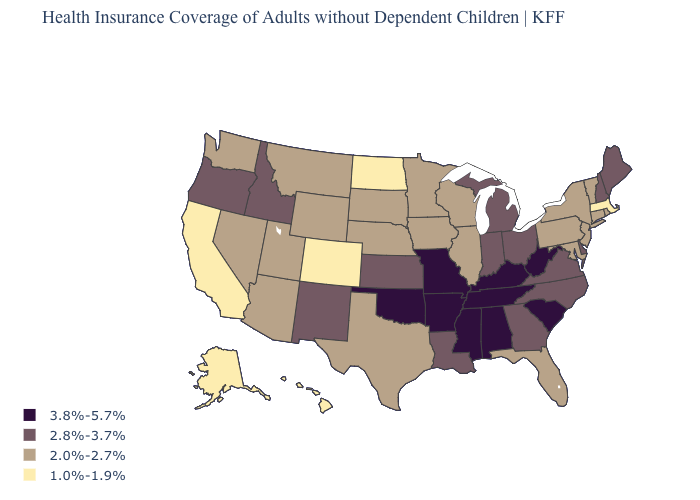What is the highest value in the USA?
Be succinct. 3.8%-5.7%. Among the states that border Kentucky , which have the lowest value?
Quick response, please. Illinois. Name the states that have a value in the range 1.0%-1.9%?
Be succinct. Alaska, California, Colorado, Hawaii, Massachusetts, North Dakota. Which states have the highest value in the USA?
Write a very short answer. Alabama, Arkansas, Kentucky, Mississippi, Missouri, Oklahoma, South Carolina, Tennessee, West Virginia. What is the value of North Dakota?
Keep it brief. 1.0%-1.9%. What is the value of Washington?
Answer briefly. 2.0%-2.7%. What is the value of Minnesota?
Short answer required. 2.0%-2.7%. What is the value of New Hampshire?
Answer briefly. 2.8%-3.7%. Name the states that have a value in the range 2.0%-2.7%?
Be succinct. Arizona, Connecticut, Florida, Illinois, Iowa, Maryland, Minnesota, Montana, Nebraska, Nevada, New Jersey, New York, Pennsylvania, Rhode Island, South Dakota, Texas, Utah, Vermont, Washington, Wisconsin, Wyoming. Does the first symbol in the legend represent the smallest category?
Be succinct. No. What is the value of Michigan?
Answer briefly. 2.8%-3.7%. Name the states that have a value in the range 2.8%-3.7%?
Answer briefly. Delaware, Georgia, Idaho, Indiana, Kansas, Louisiana, Maine, Michigan, New Hampshire, New Mexico, North Carolina, Ohio, Oregon, Virginia. Name the states that have a value in the range 2.0%-2.7%?
Quick response, please. Arizona, Connecticut, Florida, Illinois, Iowa, Maryland, Minnesota, Montana, Nebraska, Nevada, New Jersey, New York, Pennsylvania, Rhode Island, South Dakota, Texas, Utah, Vermont, Washington, Wisconsin, Wyoming. Does North Carolina have the highest value in the USA?
Quick response, please. No. Among the states that border Montana , which have the lowest value?
Quick response, please. North Dakota. 